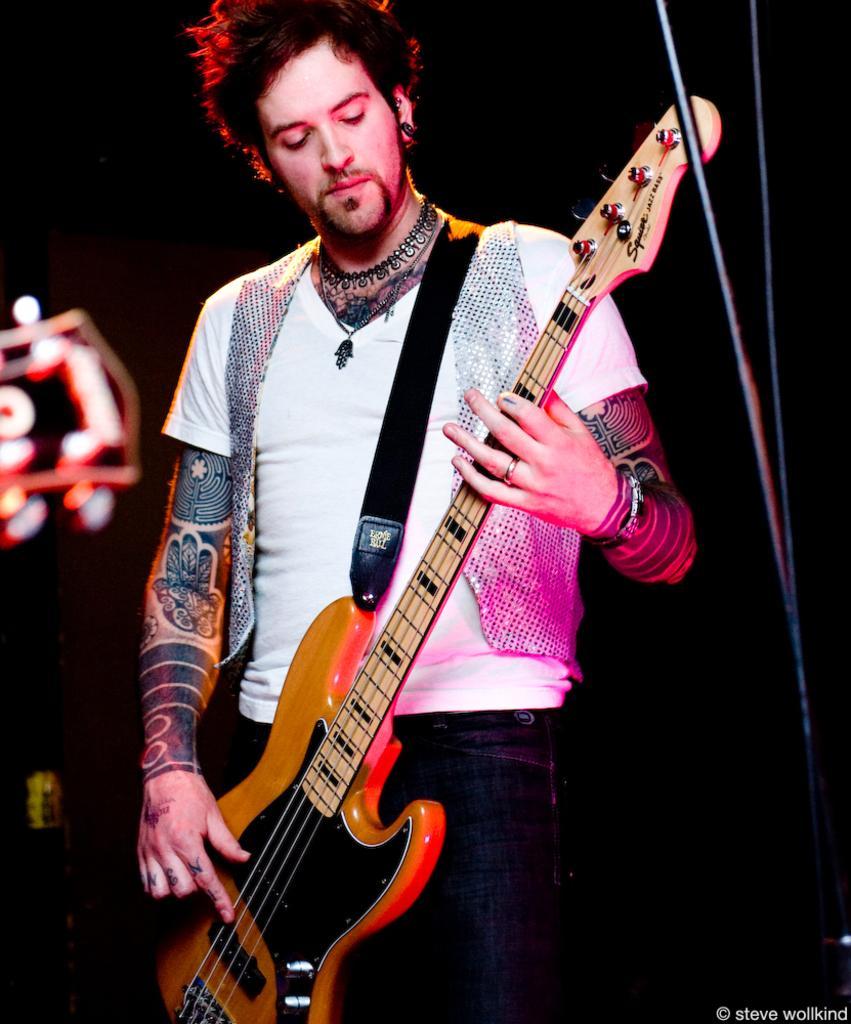How would you summarize this image in a sentence or two? In this picture we can see a man holding a guitar with his hands and standing and in the background it is dark. 